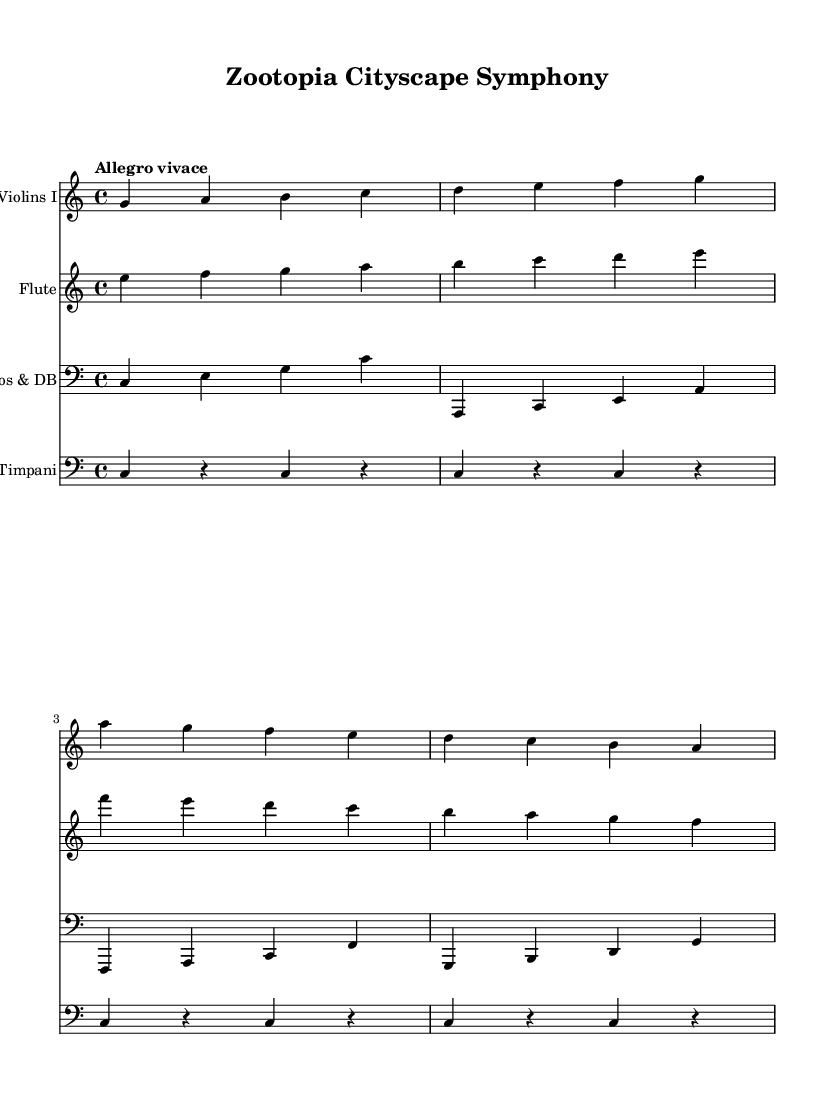What is the key signature of this music? The key signature is indicated at the beginning of the score, showing no sharps or flats, indicating C major.
Answer: C major What is the time signature of this piece? The time signature appears right after the key signature and is expressed as 4/4, which indicates four beats per measure.
Answer: 4/4 What is the tempo marking of this music? The tempo marking is written as "Allegro vivace," which suggests a lively and brisk pace.
Answer: Allegro vivace How many measures are shown in the violin part? By counting the distinct groupings of notes, we find that there are four measures in the violin part.
Answer: Four measures What is the role of the timpani in this orchestration? The timpani provide a rhythmic and punctuating role, contributing a steady pulse with repeated notes in the score.
Answer: Rhythmic punctuator How many instruments are indicated in the score? By examining the different staffed parts listed, we can identify four distinct instruments: Violins I, Flute, Cellos & Double Basses, and Timpani.
Answer: Four instruments Which instruments are in the bass clef? The staff for "Cellos & DB" and "Timpani" are marked with a bass clef, indicating that these instruments read notes in the bass clef.
Answer: Cellos & Double Basses, Timpani 